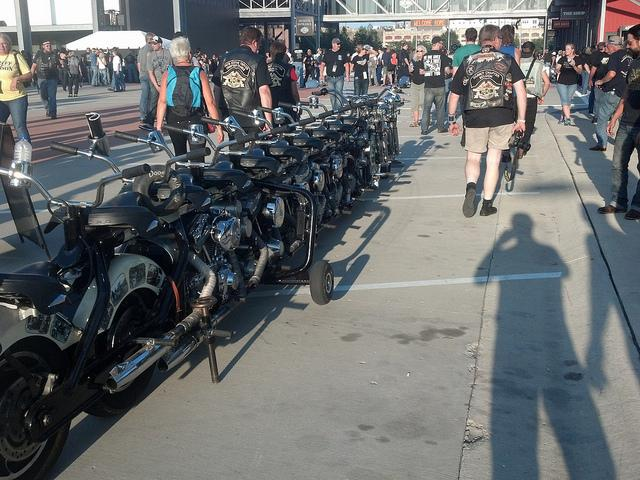What event will the people participate in? bike rally 